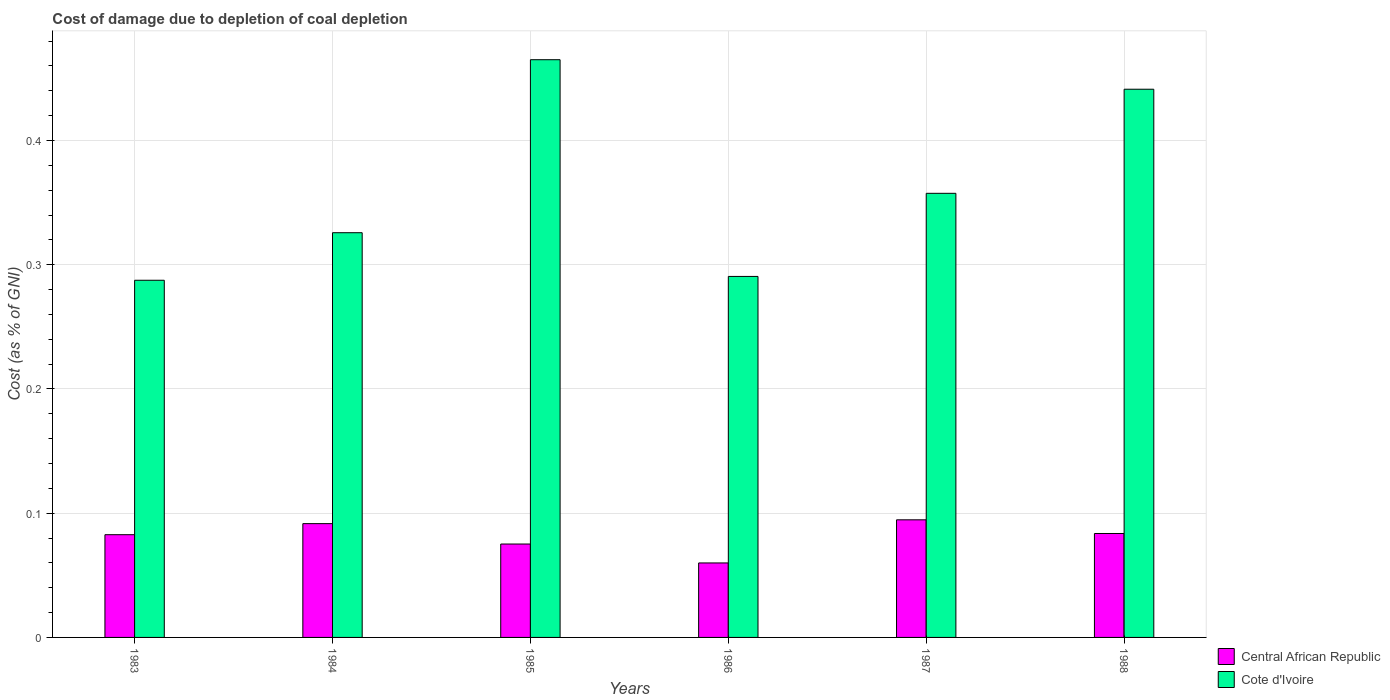How many different coloured bars are there?
Ensure brevity in your answer.  2. Are the number of bars per tick equal to the number of legend labels?
Provide a short and direct response. Yes. Are the number of bars on each tick of the X-axis equal?
Offer a terse response. Yes. How many bars are there on the 1st tick from the right?
Offer a very short reply. 2. In how many cases, is the number of bars for a given year not equal to the number of legend labels?
Ensure brevity in your answer.  0. What is the cost of damage caused due to coal depletion in Central African Republic in 1985?
Your answer should be compact. 0.08. Across all years, what is the maximum cost of damage caused due to coal depletion in Cote d'Ivoire?
Offer a very short reply. 0.46. Across all years, what is the minimum cost of damage caused due to coal depletion in Central African Republic?
Keep it short and to the point. 0.06. In which year was the cost of damage caused due to coal depletion in Central African Republic maximum?
Offer a terse response. 1987. What is the total cost of damage caused due to coal depletion in Central African Republic in the graph?
Keep it short and to the point. 0.49. What is the difference between the cost of damage caused due to coal depletion in Cote d'Ivoire in 1983 and that in 1985?
Offer a terse response. -0.18. What is the difference between the cost of damage caused due to coal depletion in Cote d'Ivoire in 1988 and the cost of damage caused due to coal depletion in Central African Republic in 1984?
Make the answer very short. 0.35. What is the average cost of damage caused due to coal depletion in Cote d'Ivoire per year?
Your response must be concise. 0.36. In the year 1988, what is the difference between the cost of damage caused due to coal depletion in Cote d'Ivoire and cost of damage caused due to coal depletion in Central African Republic?
Ensure brevity in your answer.  0.36. In how many years, is the cost of damage caused due to coal depletion in Cote d'Ivoire greater than 0.18 %?
Your answer should be very brief. 6. What is the ratio of the cost of damage caused due to coal depletion in Central African Republic in 1984 to that in 1987?
Make the answer very short. 0.97. Is the difference between the cost of damage caused due to coal depletion in Cote d'Ivoire in 1983 and 1985 greater than the difference between the cost of damage caused due to coal depletion in Central African Republic in 1983 and 1985?
Make the answer very short. No. What is the difference between the highest and the second highest cost of damage caused due to coal depletion in Cote d'Ivoire?
Provide a succinct answer. 0.02. What is the difference between the highest and the lowest cost of damage caused due to coal depletion in Cote d'Ivoire?
Make the answer very short. 0.18. In how many years, is the cost of damage caused due to coal depletion in Cote d'Ivoire greater than the average cost of damage caused due to coal depletion in Cote d'Ivoire taken over all years?
Offer a terse response. 2. What does the 2nd bar from the left in 1983 represents?
Provide a short and direct response. Cote d'Ivoire. What does the 1st bar from the right in 1986 represents?
Ensure brevity in your answer.  Cote d'Ivoire. How many bars are there?
Give a very brief answer. 12. Are the values on the major ticks of Y-axis written in scientific E-notation?
Make the answer very short. No. Does the graph contain any zero values?
Keep it short and to the point. No. Where does the legend appear in the graph?
Ensure brevity in your answer.  Bottom right. What is the title of the graph?
Offer a very short reply. Cost of damage due to depletion of coal depletion. Does "Sint Maarten (Dutch part)" appear as one of the legend labels in the graph?
Your answer should be compact. No. What is the label or title of the X-axis?
Make the answer very short. Years. What is the label or title of the Y-axis?
Provide a succinct answer. Cost (as % of GNI). What is the Cost (as % of GNI) in Central African Republic in 1983?
Offer a terse response. 0.08. What is the Cost (as % of GNI) in Cote d'Ivoire in 1983?
Your answer should be compact. 0.29. What is the Cost (as % of GNI) in Central African Republic in 1984?
Provide a succinct answer. 0.09. What is the Cost (as % of GNI) of Cote d'Ivoire in 1984?
Provide a succinct answer. 0.33. What is the Cost (as % of GNI) in Central African Republic in 1985?
Give a very brief answer. 0.08. What is the Cost (as % of GNI) in Cote d'Ivoire in 1985?
Give a very brief answer. 0.46. What is the Cost (as % of GNI) of Central African Republic in 1986?
Offer a very short reply. 0.06. What is the Cost (as % of GNI) of Cote d'Ivoire in 1986?
Your response must be concise. 0.29. What is the Cost (as % of GNI) of Central African Republic in 1987?
Make the answer very short. 0.09. What is the Cost (as % of GNI) in Cote d'Ivoire in 1987?
Make the answer very short. 0.36. What is the Cost (as % of GNI) in Central African Republic in 1988?
Your answer should be very brief. 0.08. What is the Cost (as % of GNI) in Cote d'Ivoire in 1988?
Provide a short and direct response. 0.44. Across all years, what is the maximum Cost (as % of GNI) of Central African Republic?
Offer a terse response. 0.09. Across all years, what is the maximum Cost (as % of GNI) of Cote d'Ivoire?
Keep it short and to the point. 0.46. Across all years, what is the minimum Cost (as % of GNI) of Central African Republic?
Your answer should be compact. 0.06. Across all years, what is the minimum Cost (as % of GNI) in Cote d'Ivoire?
Give a very brief answer. 0.29. What is the total Cost (as % of GNI) in Central African Republic in the graph?
Your answer should be very brief. 0.49. What is the total Cost (as % of GNI) of Cote d'Ivoire in the graph?
Provide a short and direct response. 2.17. What is the difference between the Cost (as % of GNI) of Central African Republic in 1983 and that in 1984?
Your answer should be compact. -0.01. What is the difference between the Cost (as % of GNI) of Cote d'Ivoire in 1983 and that in 1984?
Provide a succinct answer. -0.04. What is the difference between the Cost (as % of GNI) in Central African Republic in 1983 and that in 1985?
Offer a very short reply. 0.01. What is the difference between the Cost (as % of GNI) of Cote d'Ivoire in 1983 and that in 1985?
Provide a succinct answer. -0.18. What is the difference between the Cost (as % of GNI) of Central African Republic in 1983 and that in 1986?
Your answer should be very brief. 0.02. What is the difference between the Cost (as % of GNI) in Cote d'Ivoire in 1983 and that in 1986?
Your answer should be very brief. -0. What is the difference between the Cost (as % of GNI) in Central African Republic in 1983 and that in 1987?
Provide a short and direct response. -0.01. What is the difference between the Cost (as % of GNI) in Cote d'Ivoire in 1983 and that in 1987?
Provide a short and direct response. -0.07. What is the difference between the Cost (as % of GNI) in Central African Republic in 1983 and that in 1988?
Offer a very short reply. -0. What is the difference between the Cost (as % of GNI) of Cote d'Ivoire in 1983 and that in 1988?
Offer a very short reply. -0.15. What is the difference between the Cost (as % of GNI) of Central African Republic in 1984 and that in 1985?
Offer a terse response. 0.02. What is the difference between the Cost (as % of GNI) in Cote d'Ivoire in 1984 and that in 1985?
Your response must be concise. -0.14. What is the difference between the Cost (as % of GNI) in Central African Republic in 1984 and that in 1986?
Offer a terse response. 0.03. What is the difference between the Cost (as % of GNI) in Cote d'Ivoire in 1984 and that in 1986?
Provide a succinct answer. 0.04. What is the difference between the Cost (as % of GNI) of Central African Republic in 1984 and that in 1987?
Make the answer very short. -0. What is the difference between the Cost (as % of GNI) in Cote d'Ivoire in 1984 and that in 1987?
Provide a short and direct response. -0.03. What is the difference between the Cost (as % of GNI) in Central African Republic in 1984 and that in 1988?
Your answer should be compact. 0.01. What is the difference between the Cost (as % of GNI) of Cote d'Ivoire in 1984 and that in 1988?
Offer a terse response. -0.12. What is the difference between the Cost (as % of GNI) in Central African Republic in 1985 and that in 1986?
Offer a terse response. 0.02. What is the difference between the Cost (as % of GNI) of Cote d'Ivoire in 1985 and that in 1986?
Your response must be concise. 0.17. What is the difference between the Cost (as % of GNI) of Central African Republic in 1985 and that in 1987?
Your answer should be very brief. -0.02. What is the difference between the Cost (as % of GNI) of Cote d'Ivoire in 1985 and that in 1987?
Keep it short and to the point. 0.11. What is the difference between the Cost (as % of GNI) in Central African Republic in 1985 and that in 1988?
Offer a very short reply. -0.01. What is the difference between the Cost (as % of GNI) of Cote d'Ivoire in 1985 and that in 1988?
Give a very brief answer. 0.02. What is the difference between the Cost (as % of GNI) of Central African Republic in 1986 and that in 1987?
Ensure brevity in your answer.  -0.03. What is the difference between the Cost (as % of GNI) in Cote d'Ivoire in 1986 and that in 1987?
Your response must be concise. -0.07. What is the difference between the Cost (as % of GNI) of Central African Republic in 1986 and that in 1988?
Provide a short and direct response. -0.02. What is the difference between the Cost (as % of GNI) in Cote d'Ivoire in 1986 and that in 1988?
Keep it short and to the point. -0.15. What is the difference between the Cost (as % of GNI) of Central African Republic in 1987 and that in 1988?
Offer a terse response. 0.01. What is the difference between the Cost (as % of GNI) of Cote d'Ivoire in 1987 and that in 1988?
Offer a terse response. -0.08. What is the difference between the Cost (as % of GNI) in Central African Republic in 1983 and the Cost (as % of GNI) in Cote d'Ivoire in 1984?
Your response must be concise. -0.24. What is the difference between the Cost (as % of GNI) of Central African Republic in 1983 and the Cost (as % of GNI) of Cote d'Ivoire in 1985?
Your answer should be very brief. -0.38. What is the difference between the Cost (as % of GNI) in Central African Republic in 1983 and the Cost (as % of GNI) in Cote d'Ivoire in 1986?
Ensure brevity in your answer.  -0.21. What is the difference between the Cost (as % of GNI) in Central African Republic in 1983 and the Cost (as % of GNI) in Cote d'Ivoire in 1987?
Your answer should be very brief. -0.27. What is the difference between the Cost (as % of GNI) of Central African Republic in 1983 and the Cost (as % of GNI) of Cote d'Ivoire in 1988?
Provide a short and direct response. -0.36. What is the difference between the Cost (as % of GNI) of Central African Republic in 1984 and the Cost (as % of GNI) of Cote d'Ivoire in 1985?
Provide a succinct answer. -0.37. What is the difference between the Cost (as % of GNI) in Central African Republic in 1984 and the Cost (as % of GNI) in Cote d'Ivoire in 1986?
Ensure brevity in your answer.  -0.2. What is the difference between the Cost (as % of GNI) in Central African Republic in 1984 and the Cost (as % of GNI) in Cote d'Ivoire in 1987?
Provide a succinct answer. -0.27. What is the difference between the Cost (as % of GNI) in Central African Republic in 1984 and the Cost (as % of GNI) in Cote d'Ivoire in 1988?
Your answer should be compact. -0.35. What is the difference between the Cost (as % of GNI) in Central African Republic in 1985 and the Cost (as % of GNI) in Cote d'Ivoire in 1986?
Make the answer very short. -0.22. What is the difference between the Cost (as % of GNI) of Central African Republic in 1985 and the Cost (as % of GNI) of Cote d'Ivoire in 1987?
Make the answer very short. -0.28. What is the difference between the Cost (as % of GNI) in Central African Republic in 1985 and the Cost (as % of GNI) in Cote d'Ivoire in 1988?
Offer a terse response. -0.37. What is the difference between the Cost (as % of GNI) of Central African Republic in 1986 and the Cost (as % of GNI) of Cote d'Ivoire in 1987?
Ensure brevity in your answer.  -0.3. What is the difference between the Cost (as % of GNI) in Central African Republic in 1986 and the Cost (as % of GNI) in Cote d'Ivoire in 1988?
Provide a short and direct response. -0.38. What is the difference between the Cost (as % of GNI) in Central African Republic in 1987 and the Cost (as % of GNI) in Cote d'Ivoire in 1988?
Offer a very short reply. -0.35. What is the average Cost (as % of GNI) of Central African Republic per year?
Your response must be concise. 0.08. What is the average Cost (as % of GNI) in Cote d'Ivoire per year?
Give a very brief answer. 0.36. In the year 1983, what is the difference between the Cost (as % of GNI) of Central African Republic and Cost (as % of GNI) of Cote d'Ivoire?
Make the answer very short. -0.2. In the year 1984, what is the difference between the Cost (as % of GNI) of Central African Republic and Cost (as % of GNI) of Cote d'Ivoire?
Provide a succinct answer. -0.23. In the year 1985, what is the difference between the Cost (as % of GNI) of Central African Republic and Cost (as % of GNI) of Cote d'Ivoire?
Make the answer very short. -0.39. In the year 1986, what is the difference between the Cost (as % of GNI) in Central African Republic and Cost (as % of GNI) in Cote d'Ivoire?
Your answer should be compact. -0.23. In the year 1987, what is the difference between the Cost (as % of GNI) of Central African Republic and Cost (as % of GNI) of Cote d'Ivoire?
Your answer should be very brief. -0.26. In the year 1988, what is the difference between the Cost (as % of GNI) in Central African Republic and Cost (as % of GNI) in Cote d'Ivoire?
Your answer should be compact. -0.36. What is the ratio of the Cost (as % of GNI) in Central African Republic in 1983 to that in 1984?
Ensure brevity in your answer.  0.9. What is the ratio of the Cost (as % of GNI) of Cote d'Ivoire in 1983 to that in 1984?
Offer a terse response. 0.88. What is the ratio of the Cost (as % of GNI) of Central African Republic in 1983 to that in 1985?
Provide a short and direct response. 1.1. What is the ratio of the Cost (as % of GNI) in Cote d'Ivoire in 1983 to that in 1985?
Offer a terse response. 0.62. What is the ratio of the Cost (as % of GNI) in Central African Republic in 1983 to that in 1986?
Make the answer very short. 1.38. What is the ratio of the Cost (as % of GNI) of Cote d'Ivoire in 1983 to that in 1986?
Give a very brief answer. 0.99. What is the ratio of the Cost (as % of GNI) of Central African Republic in 1983 to that in 1987?
Your answer should be compact. 0.87. What is the ratio of the Cost (as % of GNI) of Cote d'Ivoire in 1983 to that in 1987?
Your answer should be compact. 0.8. What is the ratio of the Cost (as % of GNI) of Central African Republic in 1983 to that in 1988?
Your response must be concise. 0.99. What is the ratio of the Cost (as % of GNI) of Cote d'Ivoire in 1983 to that in 1988?
Provide a succinct answer. 0.65. What is the ratio of the Cost (as % of GNI) of Central African Republic in 1984 to that in 1985?
Provide a short and direct response. 1.22. What is the ratio of the Cost (as % of GNI) of Cote d'Ivoire in 1984 to that in 1985?
Give a very brief answer. 0.7. What is the ratio of the Cost (as % of GNI) of Central African Republic in 1984 to that in 1986?
Offer a very short reply. 1.53. What is the ratio of the Cost (as % of GNI) in Cote d'Ivoire in 1984 to that in 1986?
Give a very brief answer. 1.12. What is the ratio of the Cost (as % of GNI) of Central African Republic in 1984 to that in 1987?
Ensure brevity in your answer.  0.97. What is the ratio of the Cost (as % of GNI) of Cote d'Ivoire in 1984 to that in 1987?
Your answer should be very brief. 0.91. What is the ratio of the Cost (as % of GNI) of Central African Republic in 1984 to that in 1988?
Keep it short and to the point. 1.09. What is the ratio of the Cost (as % of GNI) of Cote d'Ivoire in 1984 to that in 1988?
Provide a short and direct response. 0.74. What is the ratio of the Cost (as % of GNI) in Central African Republic in 1985 to that in 1986?
Give a very brief answer. 1.25. What is the ratio of the Cost (as % of GNI) in Cote d'Ivoire in 1985 to that in 1986?
Provide a succinct answer. 1.6. What is the ratio of the Cost (as % of GNI) of Central African Republic in 1985 to that in 1987?
Your answer should be very brief. 0.79. What is the ratio of the Cost (as % of GNI) in Cote d'Ivoire in 1985 to that in 1987?
Your answer should be compact. 1.3. What is the ratio of the Cost (as % of GNI) in Central African Republic in 1985 to that in 1988?
Make the answer very short. 0.9. What is the ratio of the Cost (as % of GNI) in Cote d'Ivoire in 1985 to that in 1988?
Ensure brevity in your answer.  1.05. What is the ratio of the Cost (as % of GNI) in Central African Republic in 1986 to that in 1987?
Offer a terse response. 0.63. What is the ratio of the Cost (as % of GNI) of Cote d'Ivoire in 1986 to that in 1987?
Give a very brief answer. 0.81. What is the ratio of the Cost (as % of GNI) in Central African Republic in 1986 to that in 1988?
Your response must be concise. 0.72. What is the ratio of the Cost (as % of GNI) of Cote d'Ivoire in 1986 to that in 1988?
Ensure brevity in your answer.  0.66. What is the ratio of the Cost (as % of GNI) of Central African Republic in 1987 to that in 1988?
Provide a short and direct response. 1.13. What is the ratio of the Cost (as % of GNI) of Cote d'Ivoire in 1987 to that in 1988?
Your answer should be compact. 0.81. What is the difference between the highest and the second highest Cost (as % of GNI) of Central African Republic?
Offer a terse response. 0. What is the difference between the highest and the second highest Cost (as % of GNI) of Cote d'Ivoire?
Make the answer very short. 0.02. What is the difference between the highest and the lowest Cost (as % of GNI) in Central African Republic?
Keep it short and to the point. 0.03. What is the difference between the highest and the lowest Cost (as % of GNI) in Cote d'Ivoire?
Your answer should be very brief. 0.18. 